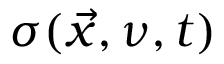Convert formula to latex. <formula><loc_0><loc_0><loc_500><loc_500>\sigma ( \vec { x } , \nu , t )</formula> 